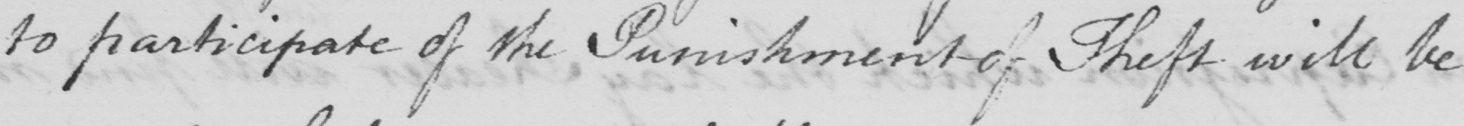What is written in this line of handwriting? to participate of the Punishment of Theft will be 